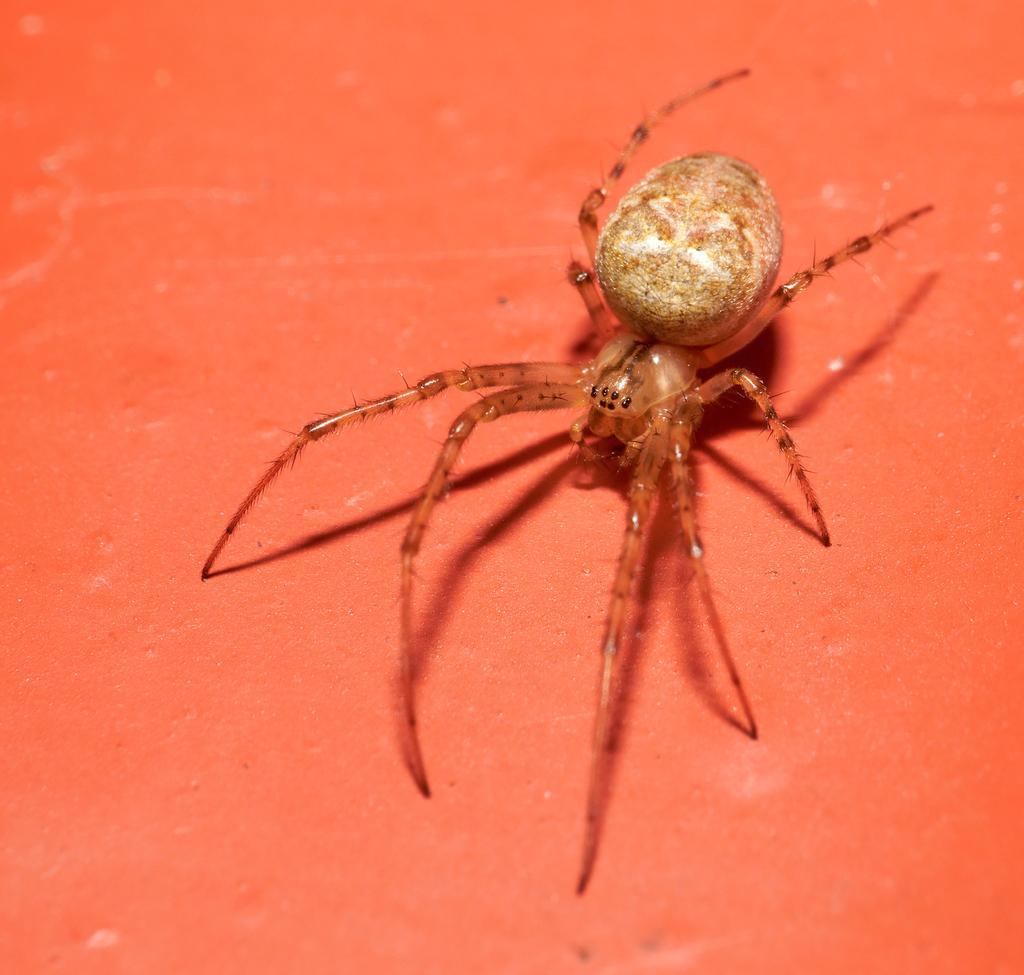In one or two sentences, can you explain what this image depicts? In this image, we can see a spider on the surface. 